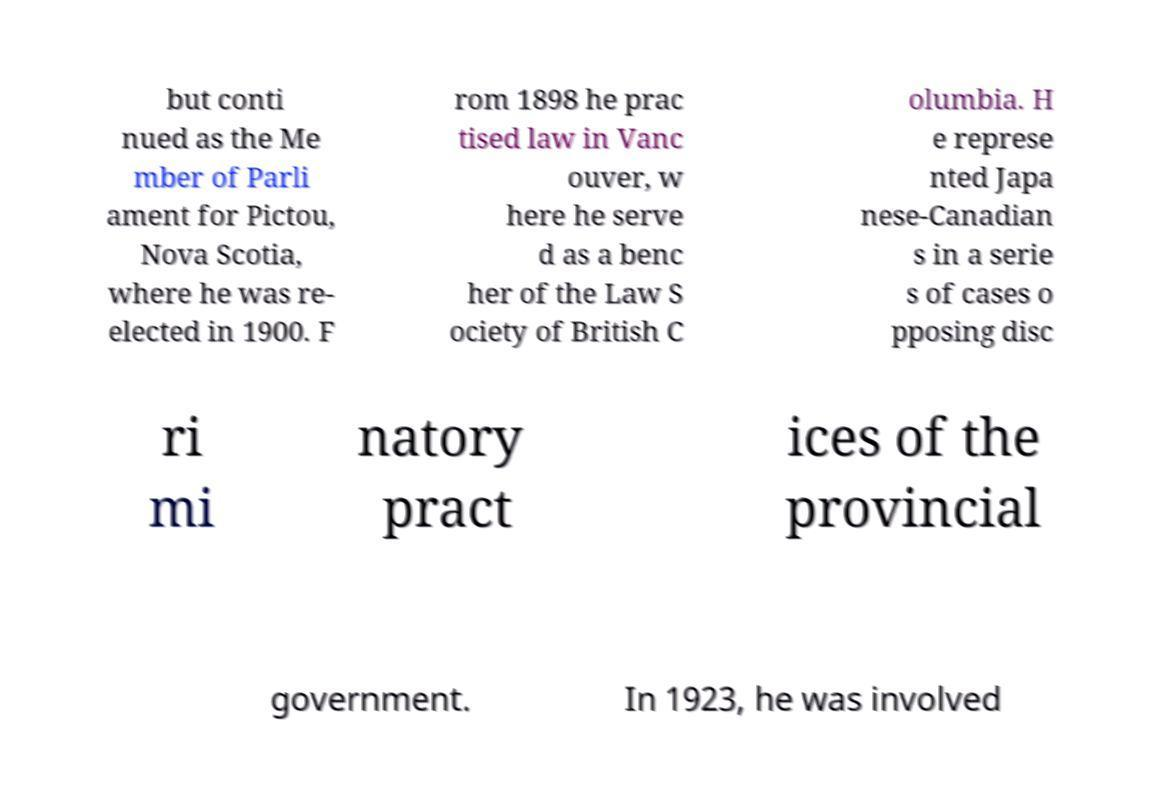Can you accurately transcribe the text from the provided image for me? but conti nued as the Me mber of Parli ament for Pictou, Nova Scotia, where he was re- elected in 1900. F rom 1898 he prac tised law in Vanc ouver, w here he serve d as a benc her of the Law S ociety of British C olumbia. H e represe nted Japa nese-Canadian s in a serie s of cases o pposing disc ri mi natory pract ices of the provincial government. In 1923, he was involved 